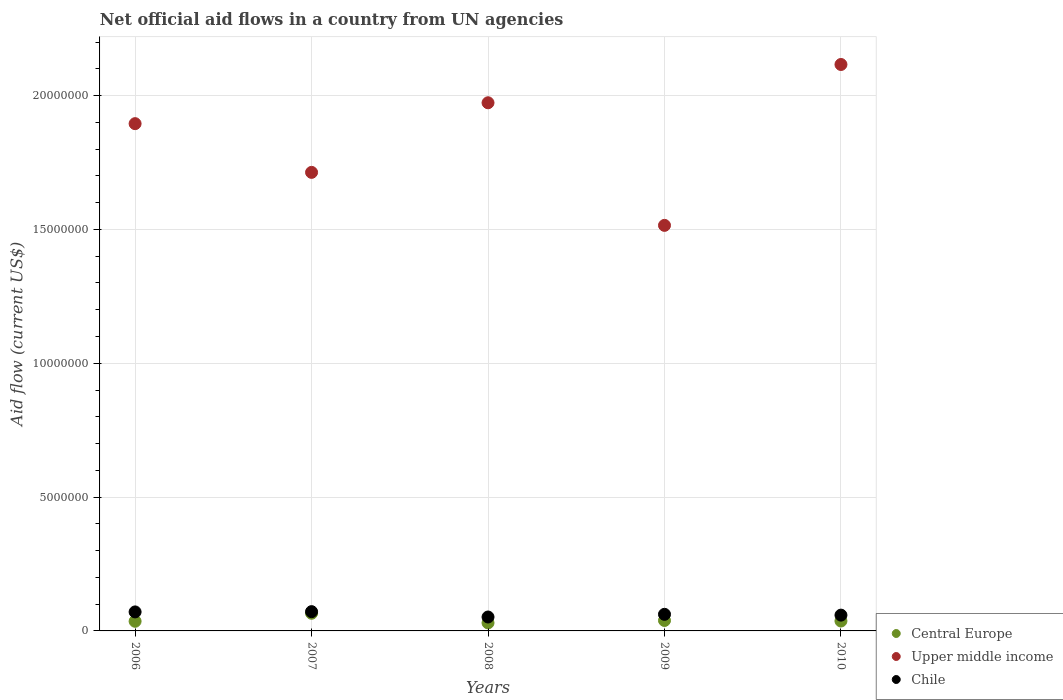Is the number of dotlines equal to the number of legend labels?
Your answer should be very brief. Yes. What is the net official aid flow in Central Europe in 2008?
Make the answer very short. 3.00e+05. Across all years, what is the maximum net official aid flow in Chile?
Your answer should be very brief. 7.20e+05. Across all years, what is the minimum net official aid flow in Chile?
Give a very brief answer. 5.20e+05. In which year was the net official aid flow in Chile maximum?
Keep it short and to the point. 2007. What is the total net official aid flow in Upper middle income in the graph?
Your answer should be compact. 9.21e+07. What is the difference between the net official aid flow in Upper middle income in 2006 and the net official aid flow in Central Europe in 2009?
Your answer should be very brief. 1.86e+07. What is the average net official aid flow in Chile per year?
Give a very brief answer. 6.32e+05. In how many years, is the net official aid flow in Central Europe greater than 18000000 US$?
Provide a short and direct response. 0. What is the ratio of the net official aid flow in Upper middle income in 2006 to that in 2007?
Provide a succinct answer. 1.11. Is the difference between the net official aid flow in Central Europe in 2007 and 2009 greater than the difference between the net official aid flow in Chile in 2007 and 2009?
Your response must be concise. Yes. What is the difference between the highest and the second highest net official aid flow in Upper middle income?
Give a very brief answer. 1.43e+06. What is the difference between the highest and the lowest net official aid flow in Central Europe?
Give a very brief answer. 3.60e+05. Is the net official aid flow in Central Europe strictly less than the net official aid flow in Chile over the years?
Your answer should be very brief. Yes. How many dotlines are there?
Keep it short and to the point. 3. How many years are there in the graph?
Give a very brief answer. 5. Are the values on the major ticks of Y-axis written in scientific E-notation?
Make the answer very short. No. Does the graph contain grids?
Keep it short and to the point. Yes. How many legend labels are there?
Ensure brevity in your answer.  3. What is the title of the graph?
Ensure brevity in your answer.  Net official aid flows in a country from UN agencies. What is the label or title of the Y-axis?
Provide a succinct answer. Aid flow (current US$). What is the Aid flow (current US$) in Central Europe in 2006?
Provide a short and direct response. 3.60e+05. What is the Aid flow (current US$) of Upper middle income in 2006?
Ensure brevity in your answer.  1.90e+07. What is the Aid flow (current US$) of Chile in 2006?
Give a very brief answer. 7.10e+05. What is the Aid flow (current US$) of Central Europe in 2007?
Your answer should be very brief. 6.60e+05. What is the Aid flow (current US$) in Upper middle income in 2007?
Keep it short and to the point. 1.71e+07. What is the Aid flow (current US$) in Chile in 2007?
Your answer should be compact. 7.20e+05. What is the Aid flow (current US$) of Central Europe in 2008?
Offer a very short reply. 3.00e+05. What is the Aid flow (current US$) of Upper middle income in 2008?
Keep it short and to the point. 1.97e+07. What is the Aid flow (current US$) of Chile in 2008?
Provide a succinct answer. 5.20e+05. What is the Aid flow (current US$) in Central Europe in 2009?
Offer a terse response. 3.90e+05. What is the Aid flow (current US$) of Upper middle income in 2009?
Your answer should be compact. 1.52e+07. What is the Aid flow (current US$) in Chile in 2009?
Keep it short and to the point. 6.20e+05. What is the Aid flow (current US$) of Upper middle income in 2010?
Keep it short and to the point. 2.12e+07. What is the Aid flow (current US$) of Chile in 2010?
Your answer should be compact. 5.90e+05. Across all years, what is the maximum Aid flow (current US$) in Upper middle income?
Offer a terse response. 2.12e+07. Across all years, what is the maximum Aid flow (current US$) of Chile?
Offer a very short reply. 7.20e+05. Across all years, what is the minimum Aid flow (current US$) of Upper middle income?
Provide a short and direct response. 1.52e+07. Across all years, what is the minimum Aid flow (current US$) of Chile?
Keep it short and to the point. 5.20e+05. What is the total Aid flow (current US$) of Central Europe in the graph?
Keep it short and to the point. 2.08e+06. What is the total Aid flow (current US$) in Upper middle income in the graph?
Keep it short and to the point. 9.21e+07. What is the total Aid flow (current US$) of Chile in the graph?
Provide a short and direct response. 3.16e+06. What is the difference between the Aid flow (current US$) in Upper middle income in 2006 and that in 2007?
Offer a very short reply. 1.82e+06. What is the difference between the Aid flow (current US$) in Central Europe in 2006 and that in 2008?
Make the answer very short. 6.00e+04. What is the difference between the Aid flow (current US$) in Upper middle income in 2006 and that in 2008?
Your answer should be very brief. -7.80e+05. What is the difference between the Aid flow (current US$) in Chile in 2006 and that in 2008?
Offer a terse response. 1.90e+05. What is the difference between the Aid flow (current US$) of Upper middle income in 2006 and that in 2009?
Offer a terse response. 3.80e+06. What is the difference between the Aid flow (current US$) of Chile in 2006 and that in 2009?
Make the answer very short. 9.00e+04. What is the difference between the Aid flow (current US$) of Central Europe in 2006 and that in 2010?
Your answer should be compact. -10000. What is the difference between the Aid flow (current US$) in Upper middle income in 2006 and that in 2010?
Ensure brevity in your answer.  -2.21e+06. What is the difference between the Aid flow (current US$) of Upper middle income in 2007 and that in 2008?
Offer a very short reply. -2.60e+06. What is the difference between the Aid flow (current US$) in Central Europe in 2007 and that in 2009?
Your response must be concise. 2.70e+05. What is the difference between the Aid flow (current US$) in Upper middle income in 2007 and that in 2009?
Your answer should be very brief. 1.98e+06. What is the difference between the Aid flow (current US$) in Chile in 2007 and that in 2009?
Make the answer very short. 1.00e+05. What is the difference between the Aid flow (current US$) of Central Europe in 2007 and that in 2010?
Make the answer very short. 2.90e+05. What is the difference between the Aid flow (current US$) of Upper middle income in 2007 and that in 2010?
Your answer should be compact. -4.03e+06. What is the difference between the Aid flow (current US$) in Chile in 2007 and that in 2010?
Your answer should be very brief. 1.30e+05. What is the difference between the Aid flow (current US$) in Upper middle income in 2008 and that in 2009?
Provide a short and direct response. 4.58e+06. What is the difference between the Aid flow (current US$) in Central Europe in 2008 and that in 2010?
Make the answer very short. -7.00e+04. What is the difference between the Aid flow (current US$) of Upper middle income in 2008 and that in 2010?
Keep it short and to the point. -1.43e+06. What is the difference between the Aid flow (current US$) of Chile in 2008 and that in 2010?
Offer a very short reply. -7.00e+04. What is the difference between the Aid flow (current US$) of Central Europe in 2009 and that in 2010?
Give a very brief answer. 2.00e+04. What is the difference between the Aid flow (current US$) of Upper middle income in 2009 and that in 2010?
Offer a terse response. -6.01e+06. What is the difference between the Aid flow (current US$) of Central Europe in 2006 and the Aid flow (current US$) of Upper middle income in 2007?
Your response must be concise. -1.68e+07. What is the difference between the Aid flow (current US$) of Central Europe in 2006 and the Aid flow (current US$) of Chile in 2007?
Your answer should be compact. -3.60e+05. What is the difference between the Aid flow (current US$) in Upper middle income in 2006 and the Aid flow (current US$) in Chile in 2007?
Offer a very short reply. 1.82e+07. What is the difference between the Aid flow (current US$) of Central Europe in 2006 and the Aid flow (current US$) of Upper middle income in 2008?
Offer a terse response. -1.94e+07. What is the difference between the Aid flow (current US$) of Upper middle income in 2006 and the Aid flow (current US$) of Chile in 2008?
Provide a succinct answer. 1.84e+07. What is the difference between the Aid flow (current US$) in Central Europe in 2006 and the Aid flow (current US$) in Upper middle income in 2009?
Your answer should be compact. -1.48e+07. What is the difference between the Aid flow (current US$) of Central Europe in 2006 and the Aid flow (current US$) of Chile in 2009?
Provide a succinct answer. -2.60e+05. What is the difference between the Aid flow (current US$) in Upper middle income in 2006 and the Aid flow (current US$) in Chile in 2009?
Keep it short and to the point. 1.83e+07. What is the difference between the Aid flow (current US$) in Central Europe in 2006 and the Aid flow (current US$) in Upper middle income in 2010?
Your response must be concise. -2.08e+07. What is the difference between the Aid flow (current US$) in Central Europe in 2006 and the Aid flow (current US$) in Chile in 2010?
Your response must be concise. -2.30e+05. What is the difference between the Aid flow (current US$) of Upper middle income in 2006 and the Aid flow (current US$) of Chile in 2010?
Your answer should be very brief. 1.84e+07. What is the difference between the Aid flow (current US$) of Central Europe in 2007 and the Aid flow (current US$) of Upper middle income in 2008?
Offer a terse response. -1.91e+07. What is the difference between the Aid flow (current US$) in Central Europe in 2007 and the Aid flow (current US$) in Chile in 2008?
Offer a terse response. 1.40e+05. What is the difference between the Aid flow (current US$) of Upper middle income in 2007 and the Aid flow (current US$) of Chile in 2008?
Give a very brief answer. 1.66e+07. What is the difference between the Aid flow (current US$) in Central Europe in 2007 and the Aid flow (current US$) in Upper middle income in 2009?
Your answer should be compact. -1.45e+07. What is the difference between the Aid flow (current US$) of Upper middle income in 2007 and the Aid flow (current US$) of Chile in 2009?
Ensure brevity in your answer.  1.65e+07. What is the difference between the Aid flow (current US$) in Central Europe in 2007 and the Aid flow (current US$) in Upper middle income in 2010?
Your answer should be very brief. -2.05e+07. What is the difference between the Aid flow (current US$) in Central Europe in 2007 and the Aid flow (current US$) in Chile in 2010?
Your answer should be compact. 7.00e+04. What is the difference between the Aid flow (current US$) in Upper middle income in 2007 and the Aid flow (current US$) in Chile in 2010?
Keep it short and to the point. 1.65e+07. What is the difference between the Aid flow (current US$) of Central Europe in 2008 and the Aid flow (current US$) of Upper middle income in 2009?
Ensure brevity in your answer.  -1.48e+07. What is the difference between the Aid flow (current US$) of Central Europe in 2008 and the Aid flow (current US$) of Chile in 2009?
Provide a short and direct response. -3.20e+05. What is the difference between the Aid flow (current US$) of Upper middle income in 2008 and the Aid flow (current US$) of Chile in 2009?
Provide a short and direct response. 1.91e+07. What is the difference between the Aid flow (current US$) of Central Europe in 2008 and the Aid flow (current US$) of Upper middle income in 2010?
Provide a short and direct response. -2.09e+07. What is the difference between the Aid flow (current US$) of Upper middle income in 2008 and the Aid flow (current US$) of Chile in 2010?
Your response must be concise. 1.91e+07. What is the difference between the Aid flow (current US$) in Central Europe in 2009 and the Aid flow (current US$) in Upper middle income in 2010?
Make the answer very short. -2.08e+07. What is the difference between the Aid flow (current US$) in Upper middle income in 2009 and the Aid flow (current US$) in Chile in 2010?
Give a very brief answer. 1.46e+07. What is the average Aid flow (current US$) of Central Europe per year?
Your answer should be compact. 4.16e+05. What is the average Aid flow (current US$) in Upper middle income per year?
Your response must be concise. 1.84e+07. What is the average Aid flow (current US$) in Chile per year?
Your answer should be very brief. 6.32e+05. In the year 2006, what is the difference between the Aid flow (current US$) of Central Europe and Aid flow (current US$) of Upper middle income?
Your response must be concise. -1.86e+07. In the year 2006, what is the difference between the Aid flow (current US$) of Central Europe and Aid flow (current US$) of Chile?
Your response must be concise. -3.50e+05. In the year 2006, what is the difference between the Aid flow (current US$) in Upper middle income and Aid flow (current US$) in Chile?
Ensure brevity in your answer.  1.82e+07. In the year 2007, what is the difference between the Aid flow (current US$) of Central Europe and Aid flow (current US$) of Upper middle income?
Keep it short and to the point. -1.65e+07. In the year 2007, what is the difference between the Aid flow (current US$) in Central Europe and Aid flow (current US$) in Chile?
Keep it short and to the point. -6.00e+04. In the year 2007, what is the difference between the Aid flow (current US$) of Upper middle income and Aid flow (current US$) of Chile?
Your answer should be compact. 1.64e+07. In the year 2008, what is the difference between the Aid flow (current US$) of Central Europe and Aid flow (current US$) of Upper middle income?
Ensure brevity in your answer.  -1.94e+07. In the year 2008, what is the difference between the Aid flow (current US$) of Upper middle income and Aid flow (current US$) of Chile?
Ensure brevity in your answer.  1.92e+07. In the year 2009, what is the difference between the Aid flow (current US$) of Central Europe and Aid flow (current US$) of Upper middle income?
Offer a terse response. -1.48e+07. In the year 2009, what is the difference between the Aid flow (current US$) of Central Europe and Aid flow (current US$) of Chile?
Offer a very short reply. -2.30e+05. In the year 2009, what is the difference between the Aid flow (current US$) in Upper middle income and Aid flow (current US$) in Chile?
Offer a terse response. 1.45e+07. In the year 2010, what is the difference between the Aid flow (current US$) in Central Europe and Aid flow (current US$) in Upper middle income?
Keep it short and to the point. -2.08e+07. In the year 2010, what is the difference between the Aid flow (current US$) of Upper middle income and Aid flow (current US$) of Chile?
Your response must be concise. 2.06e+07. What is the ratio of the Aid flow (current US$) of Central Europe in 2006 to that in 2007?
Make the answer very short. 0.55. What is the ratio of the Aid flow (current US$) in Upper middle income in 2006 to that in 2007?
Offer a terse response. 1.11. What is the ratio of the Aid flow (current US$) in Chile in 2006 to that in 2007?
Your response must be concise. 0.99. What is the ratio of the Aid flow (current US$) in Central Europe in 2006 to that in 2008?
Keep it short and to the point. 1.2. What is the ratio of the Aid flow (current US$) of Upper middle income in 2006 to that in 2008?
Your response must be concise. 0.96. What is the ratio of the Aid flow (current US$) of Chile in 2006 to that in 2008?
Provide a succinct answer. 1.37. What is the ratio of the Aid flow (current US$) of Central Europe in 2006 to that in 2009?
Your response must be concise. 0.92. What is the ratio of the Aid flow (current US$) in Upper middle income in 2006 to that in 2009?
Make the answer very short. 1.25. What is the ratio of the Aid flow (current US$) of Chile in 2006 to that in 2009?
Give a very brief answer. 1.15. What is the ratio of the Aid flow (current US$) in Central Europe in 2006 to that in 2010?
Your answer should be very brief. 0.97. What is the ratio of the Aid flow (current US$) in Upper middle income in 2006 to that in 2010?
Give a very brief answer. 0.9. What is the ratio of the Aid flow (current US$) of Chile in 2006 to that in 2010?
Give a very brief answer. 1.2. What is the ratio of the Aid flow (current US$) in Upper middle income in 2007 to that in 2008?
Offer a very short reply. 0.87. What is the ratio of the Aid flow (current US$) in Chile in 2007 to that in 2008?
Provide a succinct answer. 1.38. What is the ratio of the Aid flow (current US$) of Central Europe in 2007 to that in 2009?
Offer a very short reply. 1.69. What is the ratio of the Aid flow (current US$) in Upper middle income in 2007 to that in 2009?
Provide a short and direct response. 1.13. What is the ratio of the Aid flow (current US$) of Chile in 2007 to that in 2009?
Your answer should be compact. 1.16. What is the ratio of the Aid flow (current US$) in Central Europe in 2007 to that in 2010?
Provide a succinct answer. 1.78. What is the ratio of the Aid flow (current US$) of Upper middle income in 2007 to that in 2010?
Give a very brief answer. 0.81. What is the ratio of the Aid flow (current US$) in Chile in 2007 to that in 2010?
Provide a short and direct response. 1.22. What is the ratio of the Aid flow (current US$) of Central Europe in 2008 to that in 2009?
Ensure brevity in your answer.  0.77. What is the ratio of the Aid flow (current US$) in Upper middle income in 2008 to that in 2009?
Your answer should be very brief. 1.3. What is the ratio of the Aid flow (current US$) in Chile in 2008 to that in 2009?
Your response must be concise. 0.84. What is the ratio of the Aid flow (current US$) in Central Europe in 2008 to that in 2010?
Your answer should be compact. 0.81. What is the ratio of the Aid flow (current US$) of Upper middle income in 2008 to that in 2010?
Provide a succinct answer. 0.93. What is the ratio of the Aid flow (current US$) in Chile in 2008 to that in 2010?
Ensure brevity in your answer.  0.88. What is the ratio of the Aid flow (current US$) in Central Europe in 2009 to that in 2010?
Offer a very short reply. 1.05. What is the ratio of the Aid flow (current US$) in Upper middle income in 2009 to that in 2010?
Provide a succinct answer. 0.72. What is the ratio of the Aid flow (current US$) in Chile in 2009 to that in 2010?
Ensure brevity in your answer.  1.05. What is the difference between the highest and the second highest Aid flow (current US$) of Upper middle income?
Offer a very short reply. 1.43e+06. What is the difference between the highest and the second highest Aid flow (current US$) of Chile?
Give a very brief answer. 10000. What is the difference between the highest and the lowest Aid flow (current US$) in Upper middle income?
Provide a short and direct response. 6.01e+06. What is the difference between the highest and the lowest Aid flow (current US$) of Chile?
Make the answer very short. 2.00e+05. 